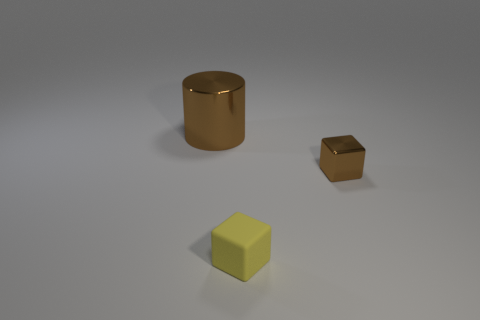Add 2 brown objects. How many objects exist? 5 Subtract all big brown metallic cylinders. Subtract all small cubes. How many objects are left? 0 Add 2 tiny matte blocks. How many tiny matte blocks are left? 3 Add 3 cylinders. How many cylinders exist? 4 Subtract all brown blocks. How many blocks are left? 1 Subtract 0 green balls. How many objects are left? 3 Subtract all cubes. How many objects are left? 1 Subtract 2 blocks. How many blocks are left? 0 Subtract all yellow cylinders. Subtract all gray spheres. How many cylinders are left? 1 Subtract all brown cylinders. How many brown blocks are left? 1 